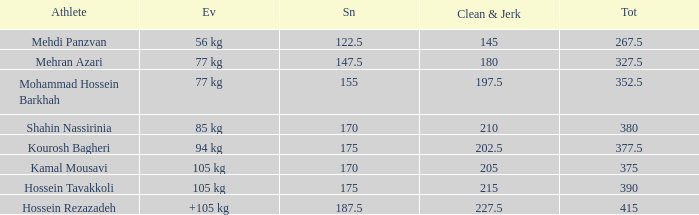What event has a 122.5 snatch rate? 56 kg. 